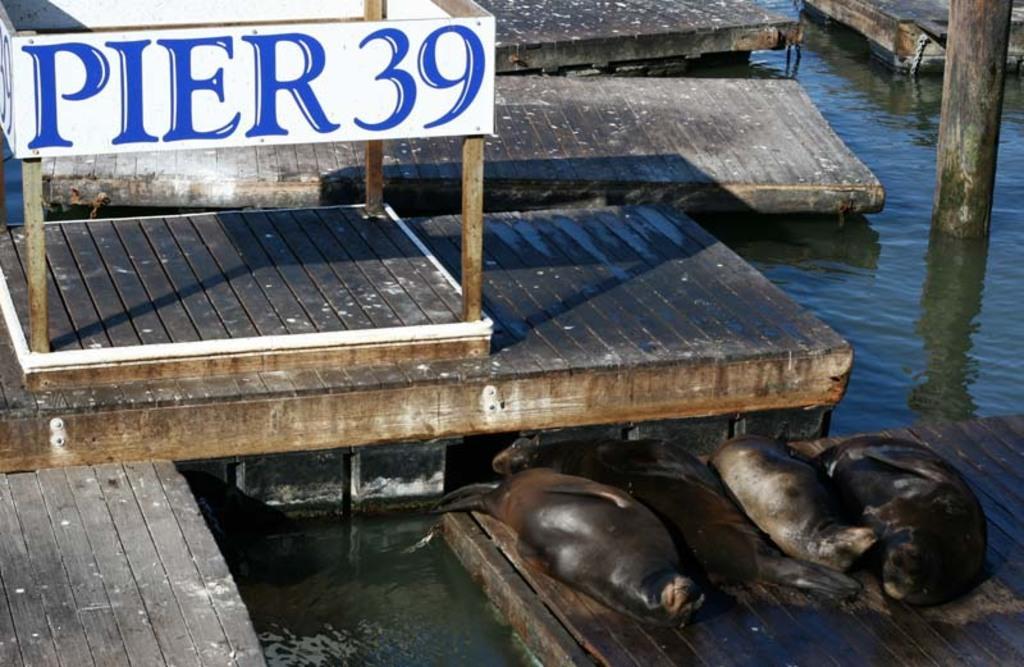Please provide a concise description of this image. In this image there are a few wooden bricks and a wooden pole on the river, there is a banner with some text, in the one of the wooden bricks there are a few seals. 